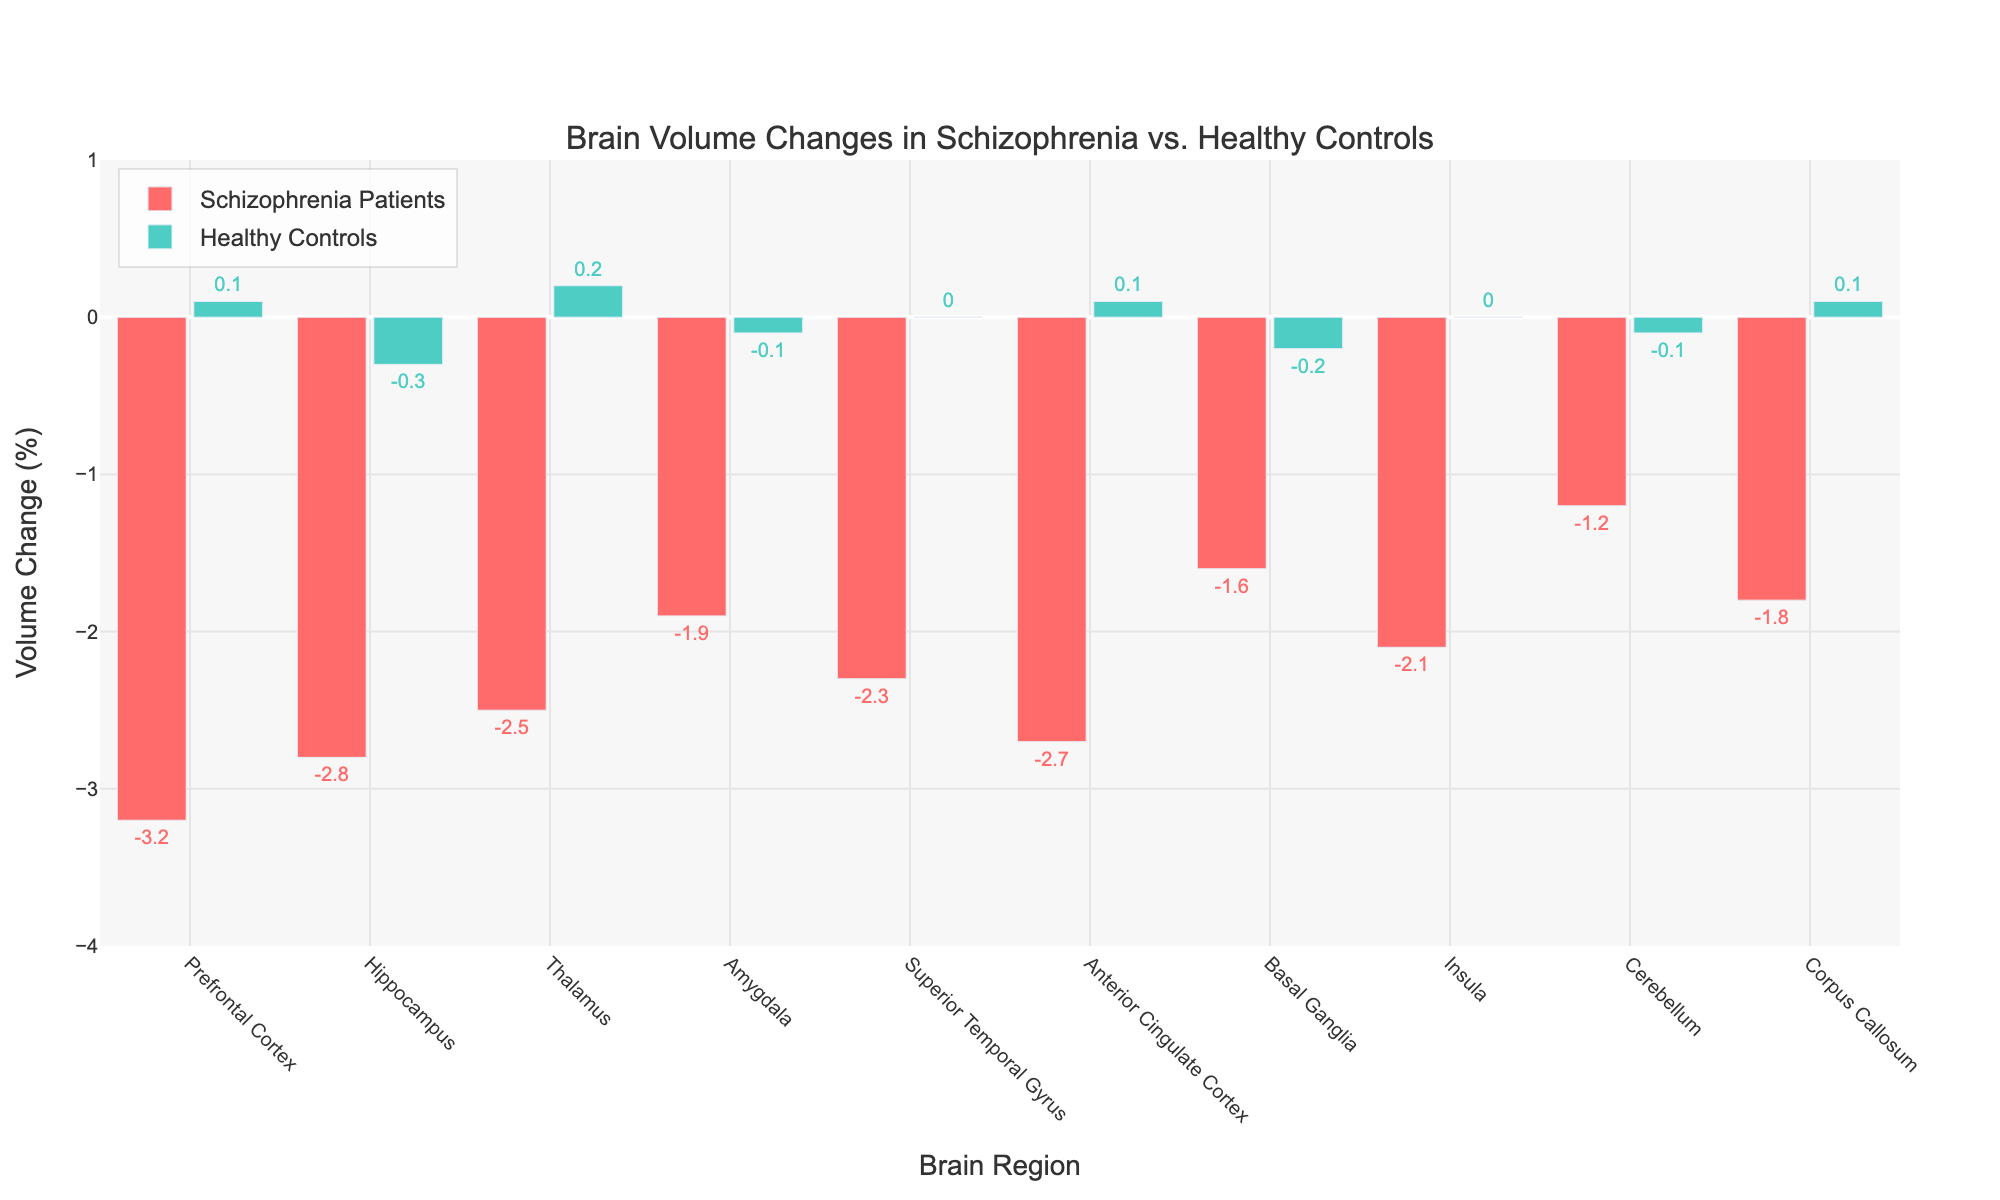Which brain region experiences the largest volume decrease in schizophrenia patients? By looking at the figure, find the brain region with the lowest bar in the "Schizophrenia Patients" category. The Prefrontal Cortex has the largest decrease at -3.2%.
Answer: Prefrontal Cortex What's the average volume change across all brain regions for healthy controls? Add the volume changes for healthy controls across all brain regions and divide by the number of regions. (0.1 - 0.3 + 0.2 - 0.1 + 0.0 + 0.1 - 0.2 + 0.0 - 0.1 + 0.1) / 10 = -0.02%.
Answer: -0.02% How much larger is the volume decrease in the hippocampus for schizophrenia patients compared to healthy controls? Subtract the volume change in healthy controls from that in schizophrenia patients for the hippocampus region. -2.8 - (-0.3) = -2.5%.
Answer: 2.5% Which region shows the most similar volume change between schizophrenia patients and healthy controls? By comparing the bars visually, look for the smallest absolute difference between the "Schizophrenia Patients" and "Healthy Controls" bars. The Superior Temporal Gyrus shows the most similar change with 0.0% for healthy controls and -2.3% for schizophrenia patients, but by numerical differences, the Insula with values of -2.1% and 0.0% respectively seems smaller (2.1% difference).
Answer: Insula Which brain regions show a positive volume change in healthy controls? Identify bars above the zero line in the "Healthy Controls" section. The regions are the Prefrontal Cortex (0.1%), Thalamus (0.2%), Anterior Cingulate Cortex (0.1%), and Corpus Callosum (0.1%).
Answer: Prefrontal Cortex, Thalamus, Anterior Cingulate Cortex, Corpus Callosum What is the combined decrease in volume percentage for the basal ganglia and cerebellum in schizophrenia patients? Add the volume changes in schizophrenia patients for the basal ganglia and cerebellum regions, which are -1.6% and -1.2% respectively. -1.6 + (-1.2) = -2.8%.
Answer: -2.8% Which regions have the smallest volume decreases in schizophrenia patients? Find the region with the smallest negative values in the "Schizophrenia Patients" category. The Cerebellum has the smallest volume decrease at -1.2%.
Answer: Cerebellum How does the volume change in the thalamus compare between schizophrenia patients and healthy controls? Compare the values for the thalamus region. Schizophrenia patients have -2.5%, while healthy controls have 0.2%.
Answer: Schizophrenia patients: -2.5%, Healthy controls: 0.2% Is there any brain region where healthy controls show a volume decrease? Look for bars below the zero line in the "Healthy Controls" category. The Hippocampus (-0.3%), Basal Ganglia (-0.2%), and Cerebellum (-0.1%) have volume decreases.
Answer: Hippocampus, Basal Ganglia, Cerebellum What's the average volume change across all brain regions for schizophrenia patients? Add the volume changes for schizophrenia patients across all brain regions and divide by the number of regions. (-3.2 -2.8 -2.5 -1.9 -2.3 -2.7 -1.6 -2.1 -1.2 -1.8)/10 = -2.21%.
Answer: -2.21% 